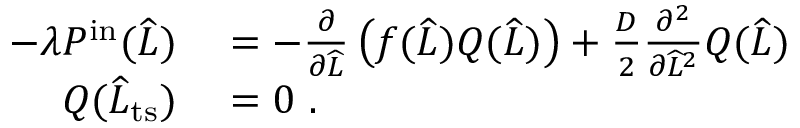<formula> <loc_0><loc_0><loc_500><loc_500>\begin{array} { r l } { - \lambda P ^ { i n } ( \widehat { L } ) } & = - \frac { \partial } { \partial \widehat { L } } \left ( f ( \widehat { L } ) Q ( \widehat { L } ) \right ) + \frac { D } { 2 } \frac { \partial ^ { 2 } } { \partial \widehat { L } ^ { 2 } } Q ( \widehat { L } ) } \\ { Q ( \widehat { L } _ { t s } ) } & = 0 \ . } \end{array}</formula> 